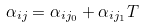<formula> <loc_0><loc_0><loc_500><loc_500>\alpha _ { i j } = \alpha _ { i j _ { 0 } } + \alpha _ { i j _ { 1 } } T</formula> 